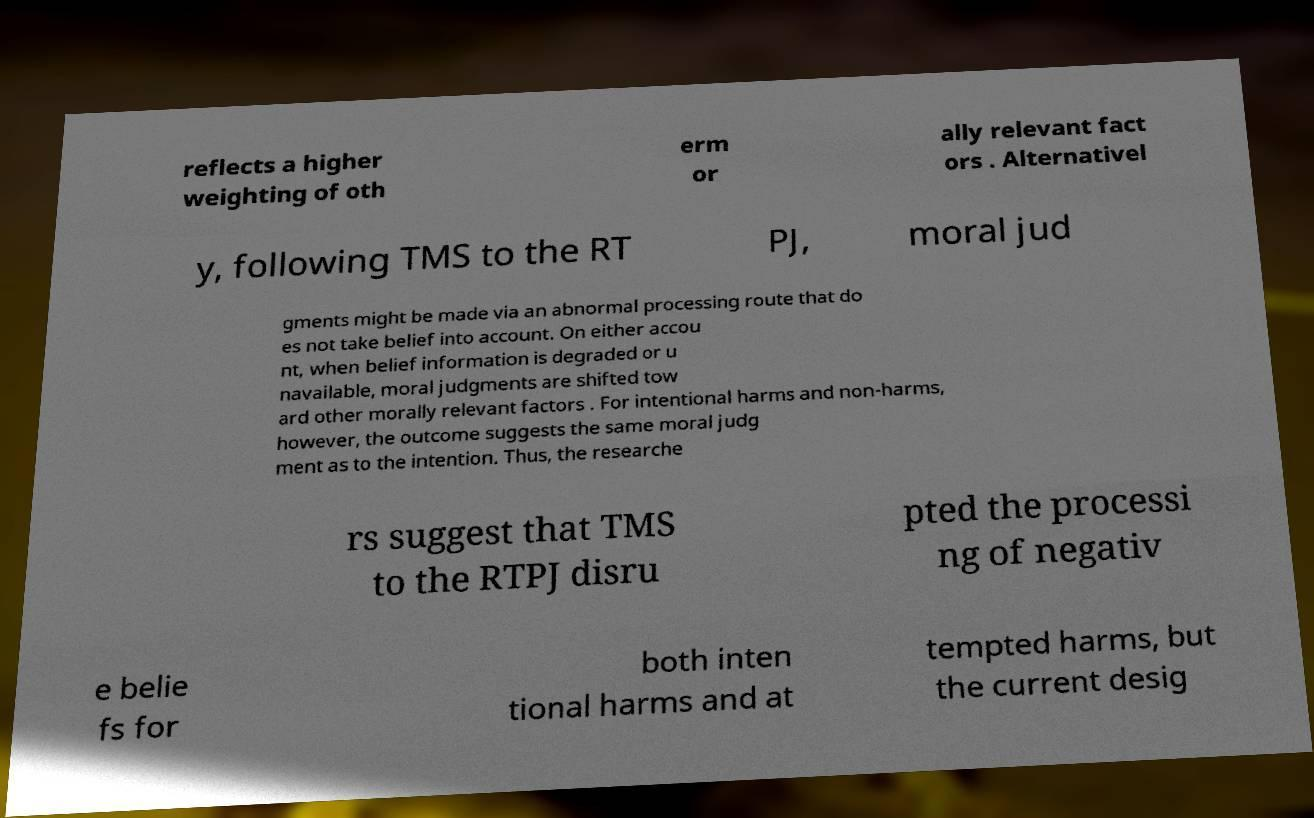There's text embedded in this image that I need extracted. Can you transcribe it verbatim? reflects a higher weighting of oth erm or ally relevant fact ors . Alternativel y, following TMS to the RT PJ, moral jud gments might be made via an abnormal processing route that do es not take belief into account. On either accou nt, when belief information is degraded or u navailable, moral judgments are shifted tow ard other morally relevant factors . For intentional harms and non-harms, however, the outcome suggests the same moral judg ment as to the intention. Thus, the researche rs suggest that TMS to the RTPJ disru pted the processi ng of negativ e belie fs for both inten tional harms and at tempted harms, but the current desig 